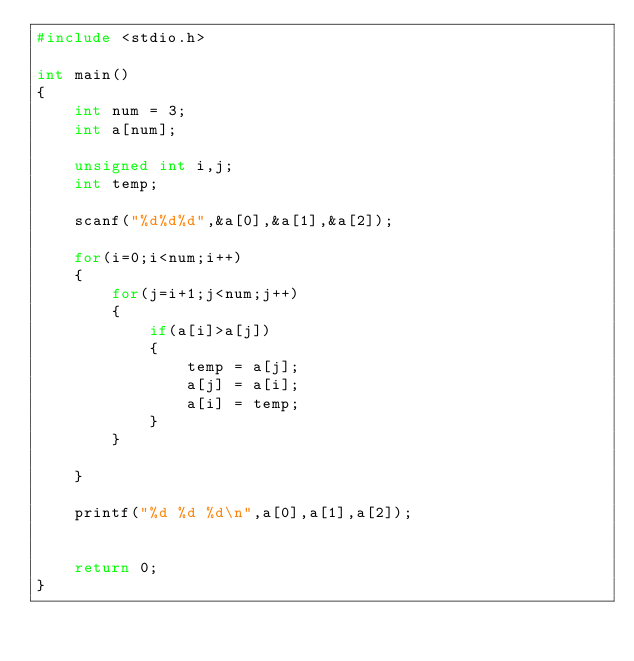<code> <loc_0><loc_0><loc_500><loc_500><_C_>#include <stdio.h>

int main()
{
    int num = 3;
    int a[num];

    unsigned int i,j;
    int temp;
 
    scanf("%d%d%d",&a[0],&a[1],&a[2]);
    
    for(i=0;i<num;i++)
    {
        for(j=i+1;j<num;j++)
        {
            if(a[i]>a[j])
            {
                temp = a[j];
                a[j] = a[i];
                a[i] = temp;
            }
        } 
        
    }
    
    printf("%d %d %d\n",a[0],a[1],a[2]);
   

    return 0;
}</code> 